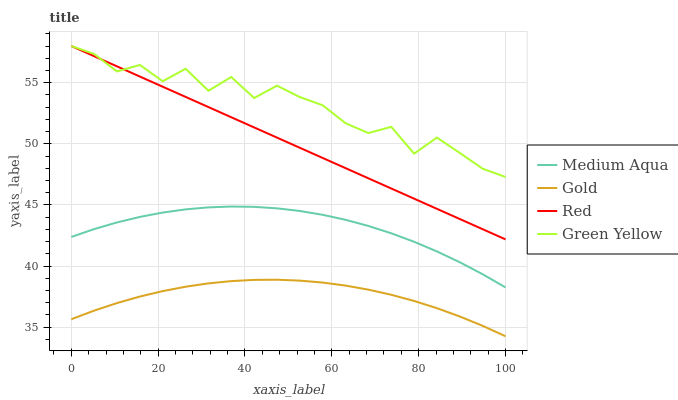Does Gold have the minimum area under the curve?
Answer yes or no. Yes. Does Green Yellow have the maximum area under the curve?
Answer yes or no. Yes. Does Medium Aqua have the minimum area under the curve?
Answer yes or no. No. Does Medium Aqua have the maximum area under the curve?
Answer yes or no. No. Is Red the smoothest?
Answer yes or no. Yes. Is Green Yellow the roughest?
Answer yes or no. Yes. Is Medium Aqua the smoothest?
Answer yes or no. No. Is Medium Aqua the roughest?
Answer yes or no. No. Does Gold have the lowest value?
Answer yes or no. Yes. Does Medium Aqua have the lowest value?
Answer yes or no. No. Does Red have the highest value?
Answer yes or no. Yes. Does Medium Aqua have the highest value?
Answer yes or no. No. Is Gold less than Red?
Answer yes or no. Yes. Is Green Yellow greater than Medium Aqua?
Answer yes or no. Yes. Does Green Yellow intersect Red?
Answer yes or no. Yes. Is Green Yellow less than Red?
Answer yes or no. No. Is Green Yellow greater than Red?
Answer yes or no. No. Does Gold intersect Red?
Answer yes or no. No. 